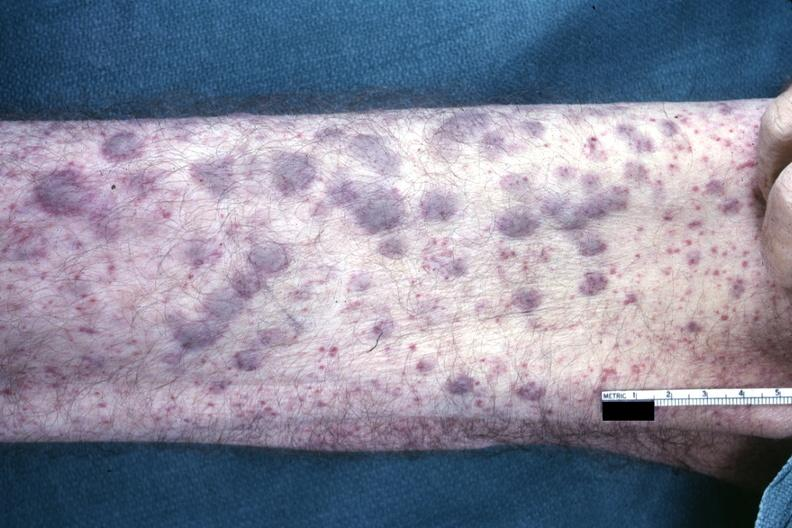s choanal patency present?
Answer the question using a single word or phrase. No 